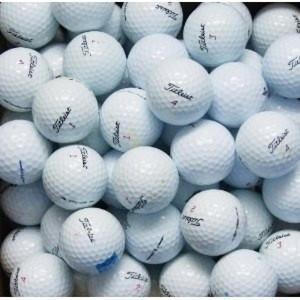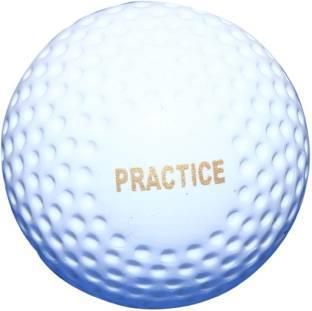The first image is the image on the left, the second image is the image on the right. Given the left and right images, does the statement "All golf balls shown are plain and unmarked." hold true? Answer yes or no. No. 